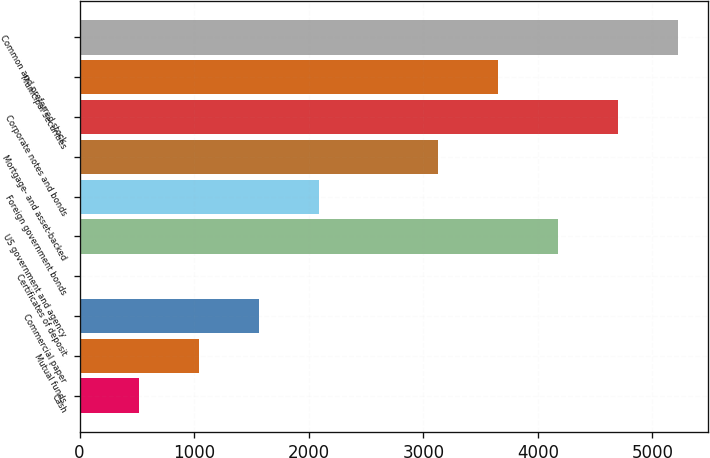Convert chart. <chart><loc_0><loc_0><loc_500><loc_500><bar_chart><fcel>Cash<fcel>Mutual funds<fcel>Commercial paper<fcel>Certificates of deposit<fcel>US government and agency<fcel>Foreign government bonds<fcel>Mortgage- and asset-backed<fcel>Corporate notes and bonds<fcel>Municipal securities<fcel>Common and preferred stock<nl><fcel>522.68<fcel>1044.6<fcel>1566.52<fcel>0.76<fcel>4176.12<fcel>2088.44<fcel>3132.28<fcel>4698.04<fcel>3654.2<fcel>5219.96<nl></chart> 